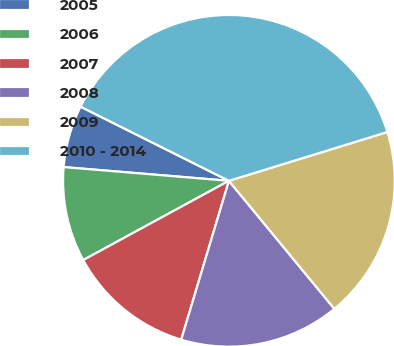<chart> <loc_0><loc_0><loc_500><loc_500><pie_chart><fcel>2005<fcel>2006<fcel>2007<fcel>2008<fcel>2009<fcel>2010 - 2014<nl><fcel>6.06%<fcel>9.25%<fcel>12.43%<fcel>15.61%<fcel>18.79%<fcel>37.87%<nl></chart> 